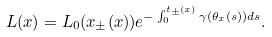<formula> <loc_0><loc_0><loc_500><loc_500>L ( x ) = L _ { 0 } ( x _ { \pm } ( x ) ) e ^ { - \int _ { 0 } ^ { t _ { \pm } ( x ) } \gamma ( \theta _ { x } ( s ) ) d s } .</formula> 